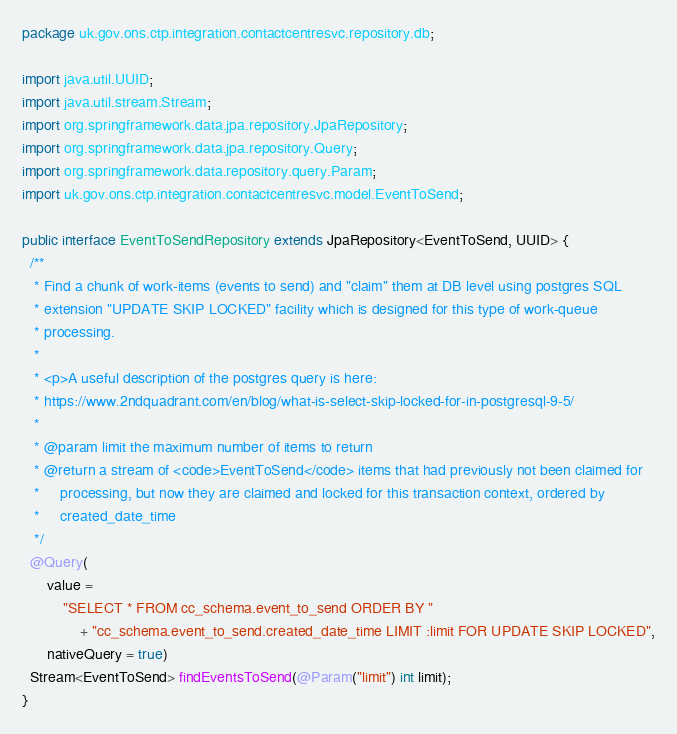Convert code to text. <code><loc_0><loc_0><loc_500><loc_500><_Java_>package uk.gov.ons.ctp.integration.contactcentresvc.repository.db;

import java.util.UUID;
import java.util.stream.Stream;
import org.springframework.data.jpa.repository.JpaRepository;
import org.springframework.data.jpa.repository.Query;
import org.springframework.data.repository.query.Param;
import uk.gov.ons.ctp.integration.contactcentresvc.model.EventToSend;

public interface EventToSendRepository extends JpaRepository<EventToSend, UUID> {
  /**
   * Find a chunk of work-items (events to send) and "claim" them at DB level using postgres SQL
   * extension "UPDATE SKIP LOCKED" facility which is designed for this type of work-queue
   * processing.
   *
   * <p>A useful description of the postgres query is here:
   * https://www.2ndquadrant.com/en/blog/what-is-select-skip-locked-for-in-postgresql-9-5/
   *
   * @param limit the maximum number of items to return
   * @return a stream of <code>EventToSend</code> items that had previously not been claimed for
   *     processing, but now they are claimed and locked for this transaction context, ordered by
   *     created_date_time
   */
  @Query(
      value =
          "SELECT * FROM cc_schema.event_to_send ORDER BY "
              + "cc_schema.event_to_send.created_date_time LIMIT :limit FOR UPDATE SKIP LOCKED",
      nativeQuery = true)
  Stream<EventToSend> findEventsToSend(@Param("limit") int limit);
}
</code> 